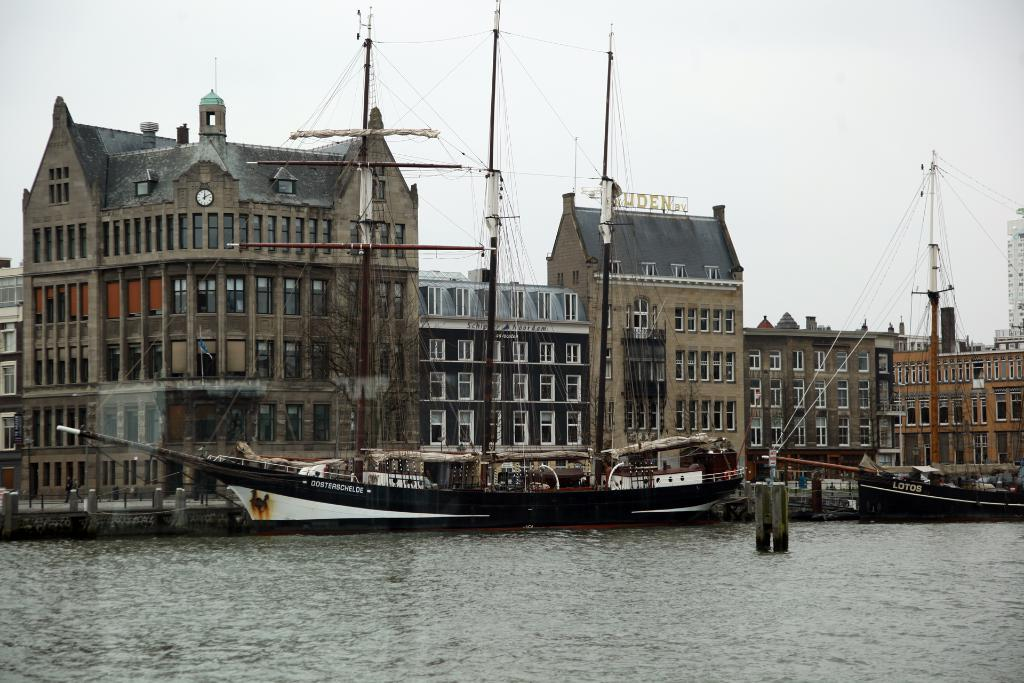What type of structures can be seen in the image? There are buildings in the image. What is located in front of the buildings? There are boats and a bridge in front of the buildings. What is visible at the top of the image? The sky is visible at the top of the image. What is visible at the bottom of the image? Water is visible at the bottom of the image. What type of song can be heard playing from the alarm in the image? There is no alarm or song present in the image. 